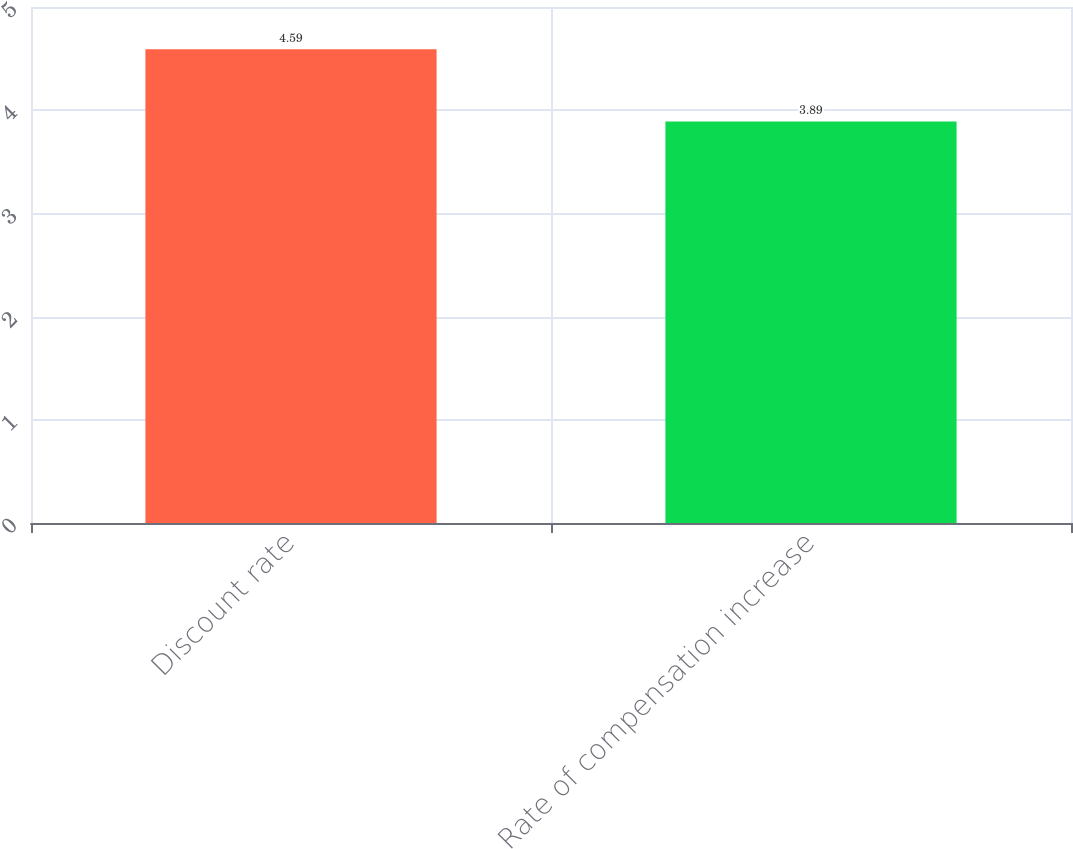Convert chart. <chart><loc_0><loc_0><loc_500><loc_500><bar_chart><fcel>Discount rate<fcel>Rate of compensation increase<nl><fcel>4.59<fcel>3.89<nl></chart> 